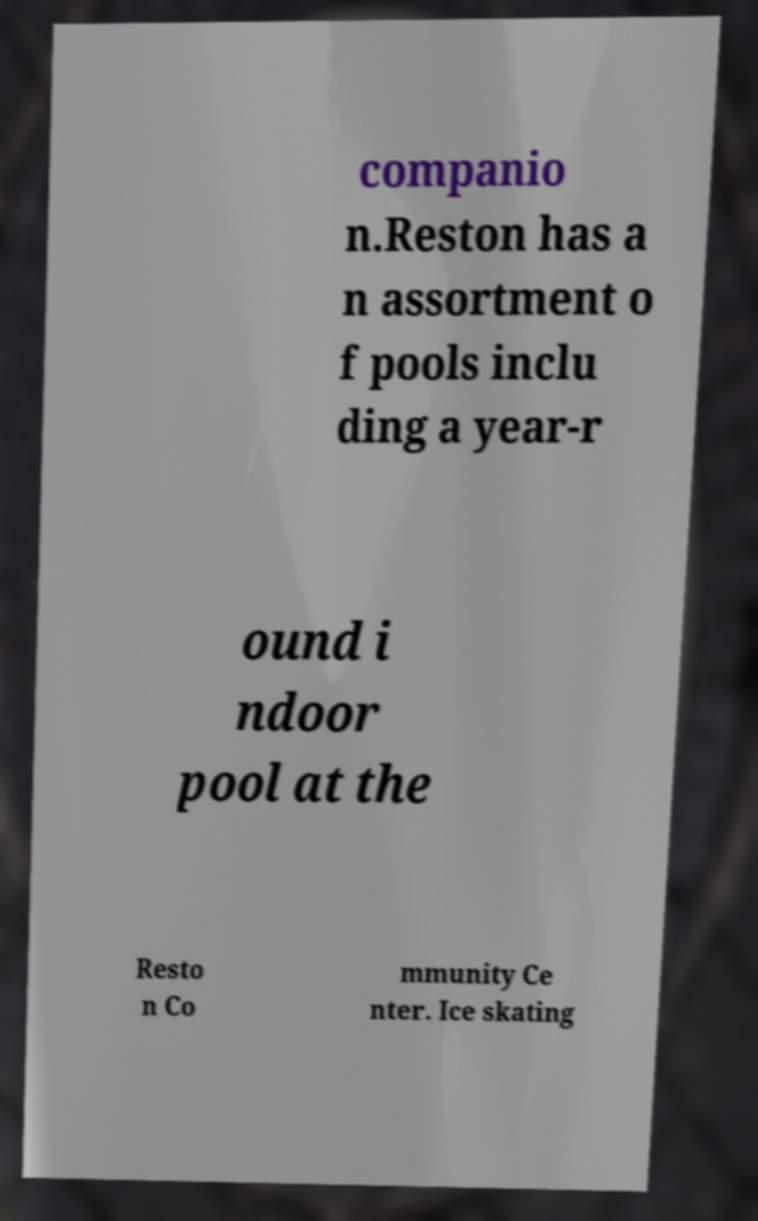Could you assist in decoding the text presented in this image and type it out clearly? companio n.Reston has a n assortment o f pools inclu ding a year-r ound i ndoor pool at the Resto n Co mmunity Ce nter. Ice skating 